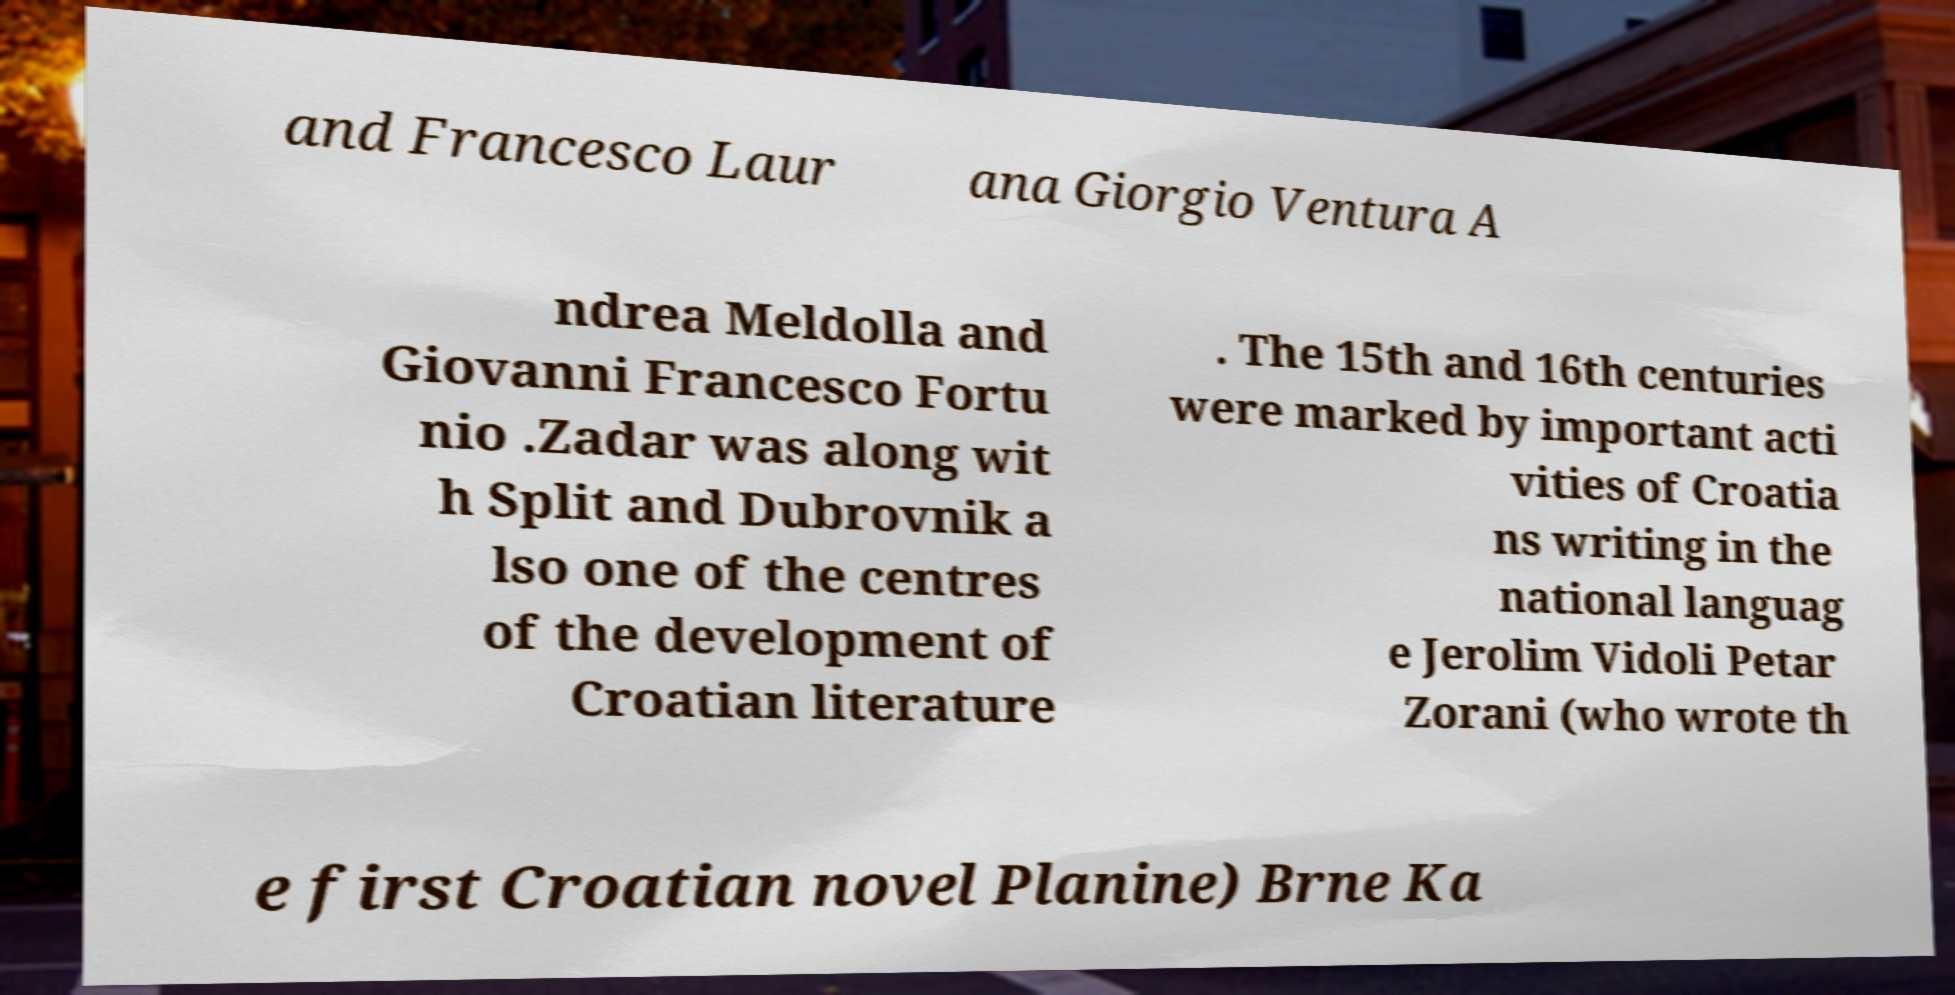Please identify and transcribe the text found in this image. and Francesco Laur ana Giorgio Ventura A ndrea Meldolla and Giovanni Francesco Fortu nio .Zadar was along wit h Split and Dubrovnik a lso one of the centres of the development of Croatian literature . The 15th and 16th centuries were marked by important acti vities of Croatia ns writing in the national languag e Jerolim Vidoli Petar Zorani (who wrote th e first Croatian novel Planine) Brne Ka 